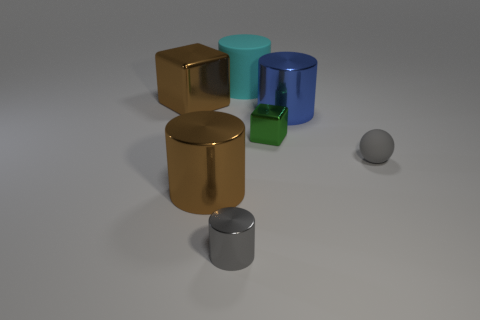What number of shiny things are either tiny things or small green blocks?
Provide a short and direct response. 2. Is the number of things that are left of the tiny cylinder less than the number of gray objects that are in front of the blue metal cylinder?
Your answer should be compact. No. There is a big brown metallic object that is in front of the tiny gray thing that is right of the small green block; are there any big shiny objects on the left side of it?
Offer a very short reply. Yes. What is the material of the thing that is the same color as the ball?
Ensure brevity in your answer.  Metal. Do the matte object that is on the left side of the big blue metal cylinder and the blue metallic object behind the small ball have the same shape?
Ensure brevity in your answer.  Yes. There is a block that is the same size as the blue metal thing; what is its material?
Offer a terse response. Metal. Are the small gray thing that is to the left of the rubber cylinder and the brown object that is in front of the small green thing made of the same material?
Give a very brief answer. Yes. What shape is the matte object that is the same size as the gray shiny object?
Provide a short and direct response. Sphere. What number of other objects are there of the same color as the large matte cylinder?
Provide a succinct answer. 0. There is a matte ball in front of the brown block; what color is it?
Keep it short and to the point. Gray. 